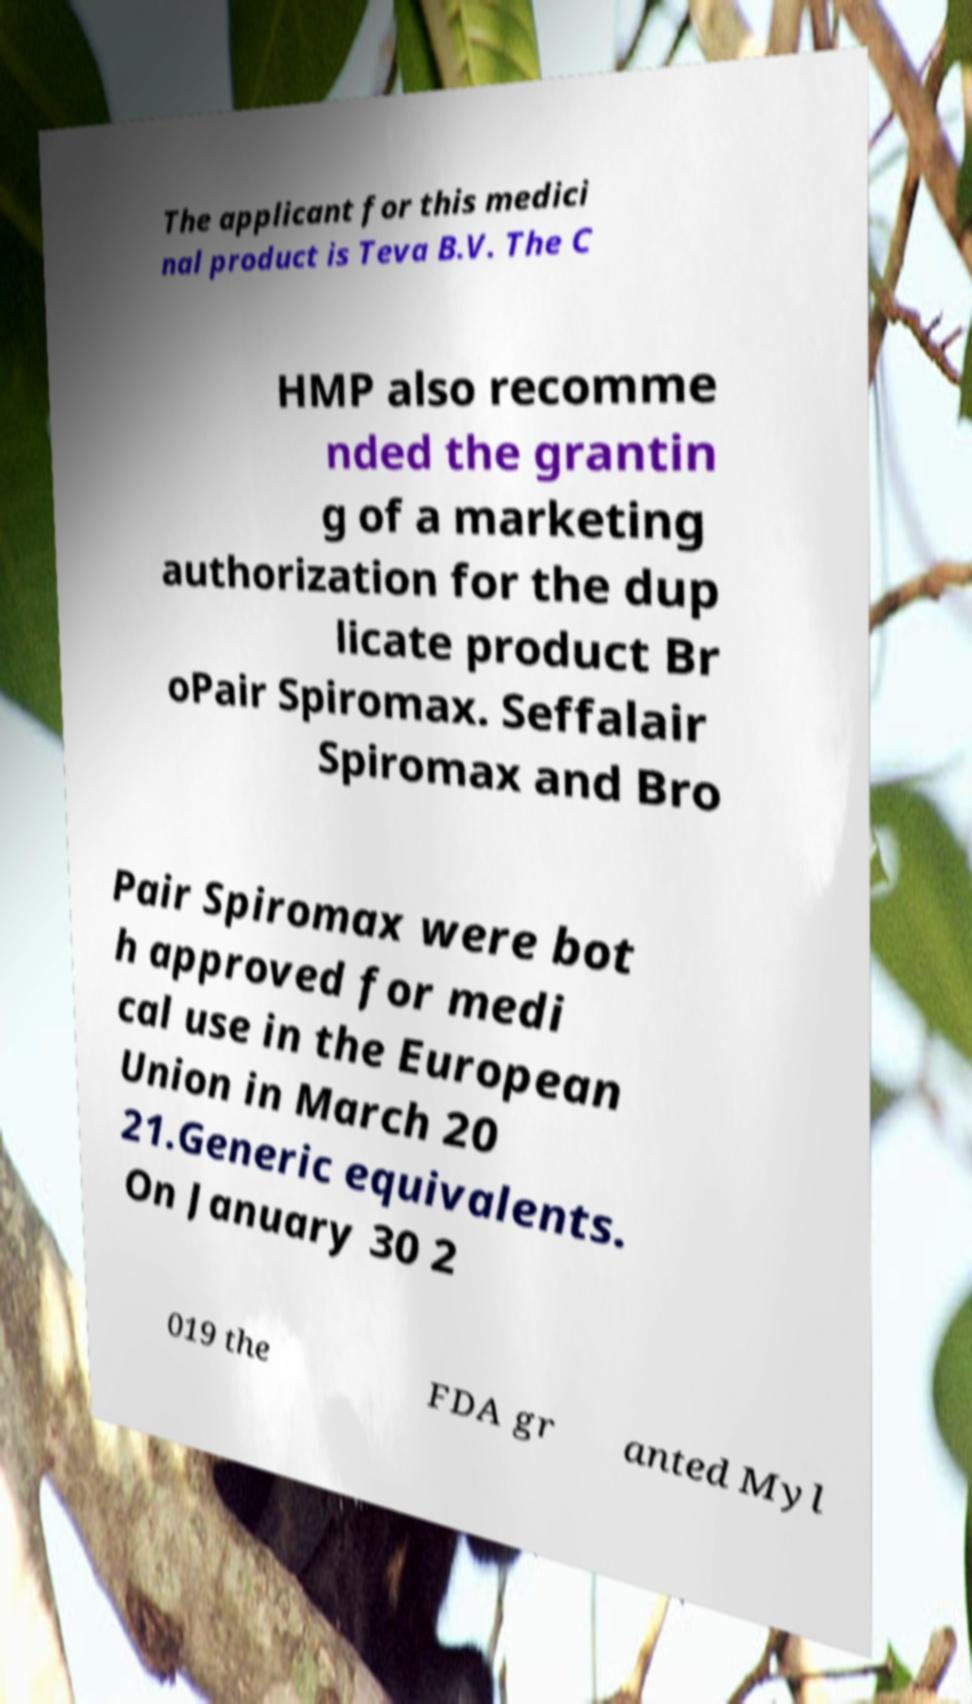I need the written content from this picture converted into text. Can you do that? The applicant for this medici nal product is Teva B.V. The C HMP also recomme nded the grantin g of a marketing authorization for the dup licate product Br oPair Spiromax. Seffalair Spiromax and Bro Pair Spiromax were bot h approved for medi cal use in the European Union in March 20 21.Generic equivalents. On January 30 2 019 the FDA gr anted Myl 